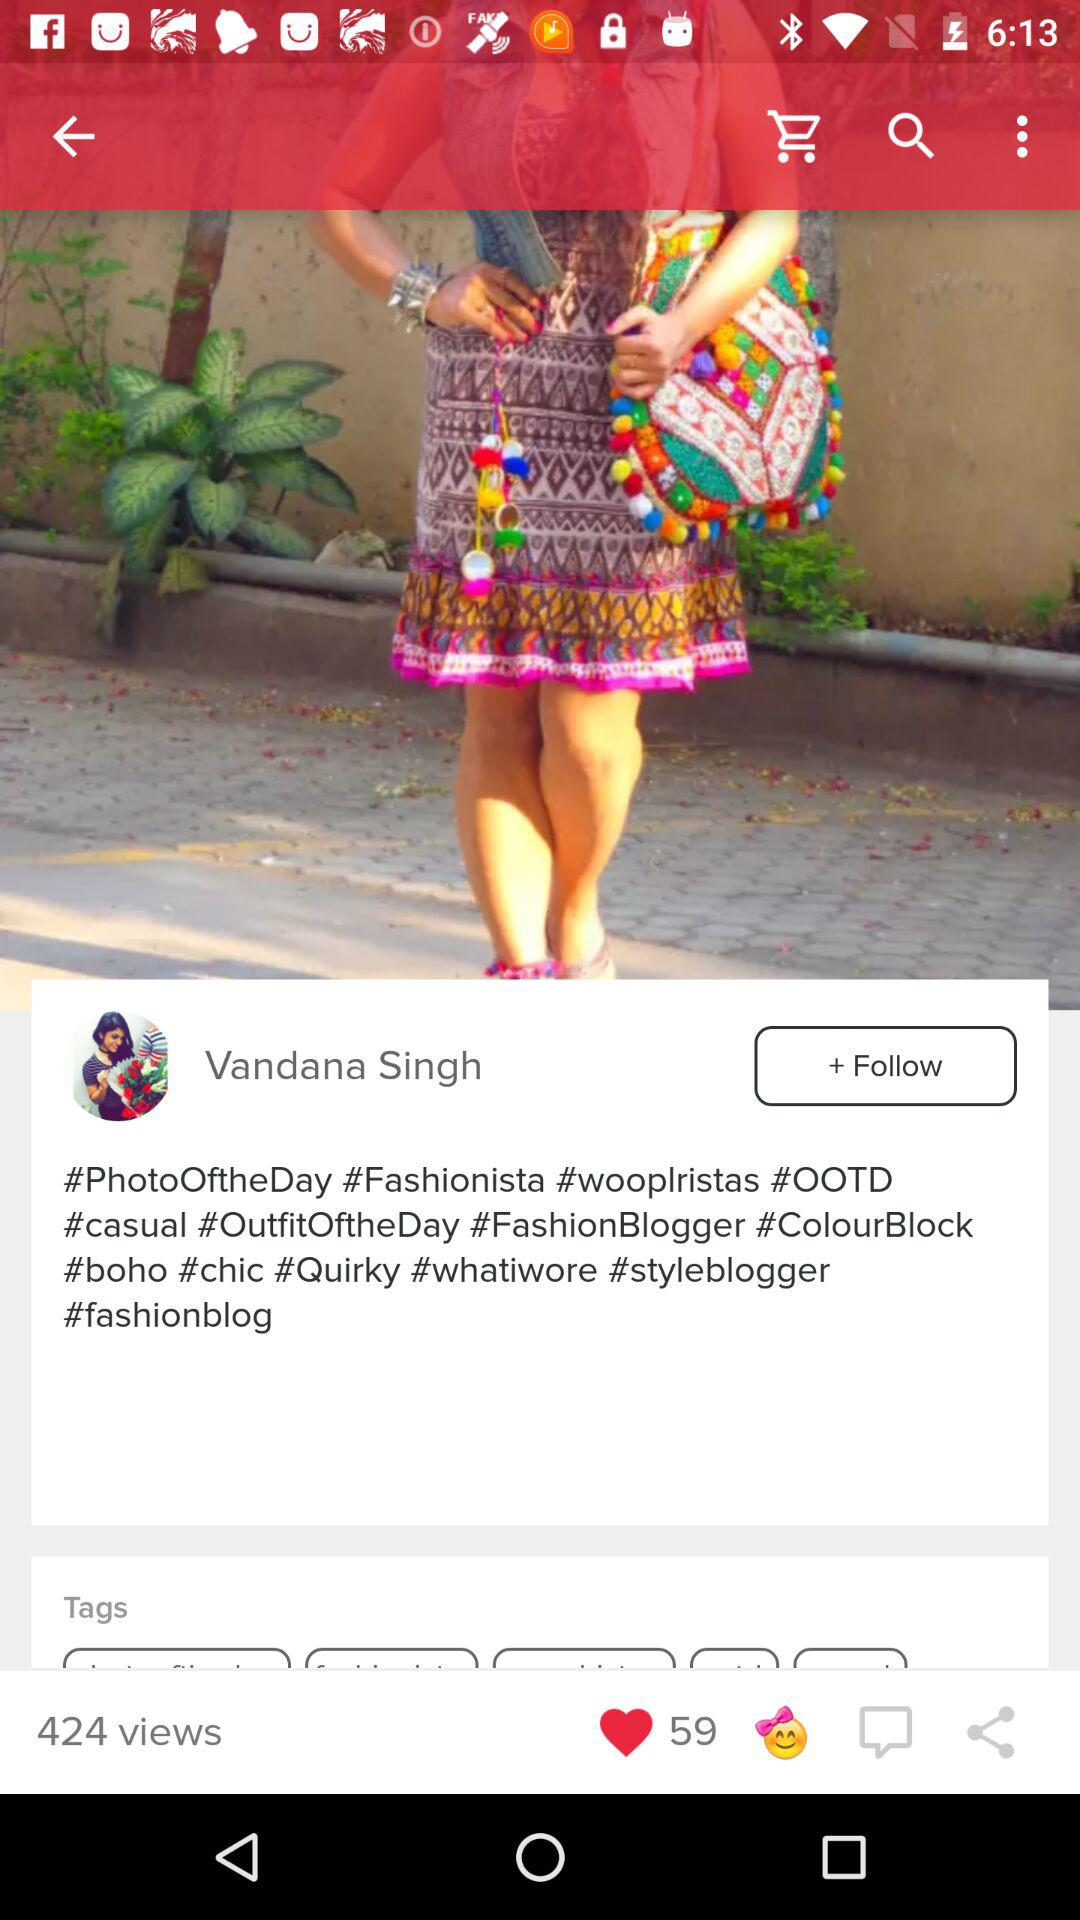How many views are there? There are 424 views. 